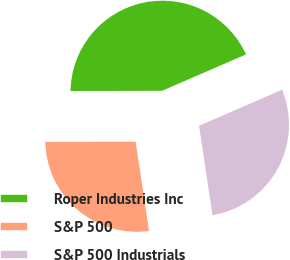Convert chart to OTSL. <chart><loc_0><loc_0><loc_500><loc_500><pie_chart><fcel>Roper Industries Inc<fcel>S&P 500<fcel>S&P 500 Industrials<nl><fcel>43.52%<fcel>27.33%<fcel>29.14%<nl></chart> 